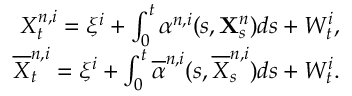Convert formula to latex. <formula><loc_0><loc_0><loc_500><loc_500>\begin{array} { r } { X _ { t } ^ { n , i } = \xi ^ { i } + \int _ { 0 } ^ { t } \alpha ^ { n , i } ( s , X _ { s } ^ { n } ) d s + W _ { t } ^ { i } , } \\ { \overline { X } _ { t } ^ { n , i } = \xi ^ { i } + \int _ { 0 } ^ { t } \overline { \alpha } ^ { n , i } ( s , \overline { X } _ { s } ^ { n , i } ) d s + W _ { t } ^ { i } . } \end{array}</formula> 